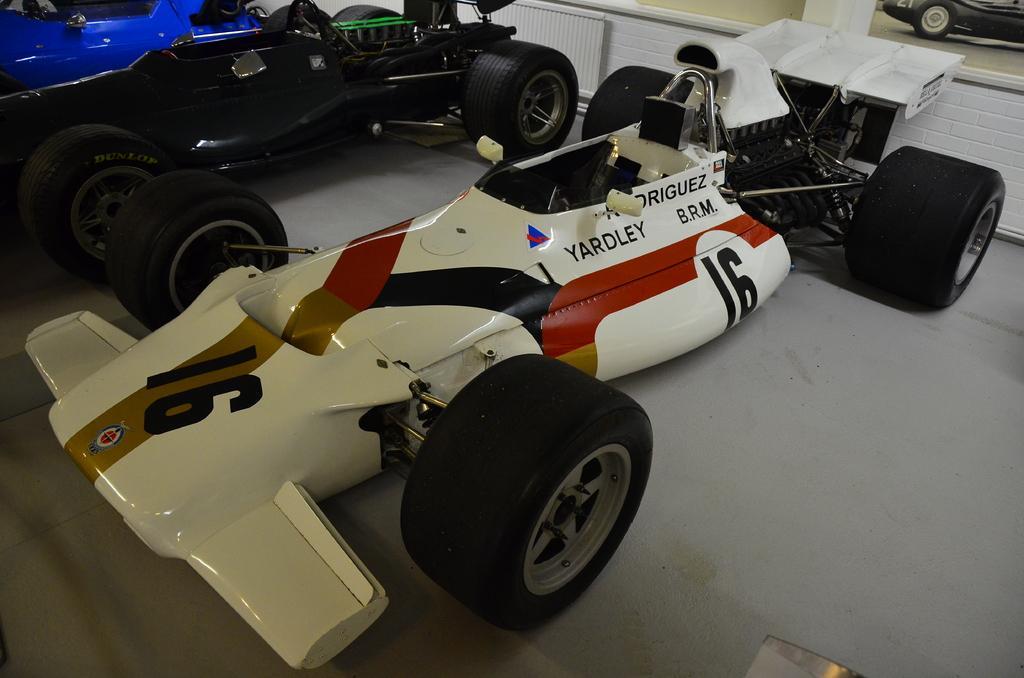How would you summarize this image in a sentence or two? This picture shows few cars and they are white, black and blue in color. 